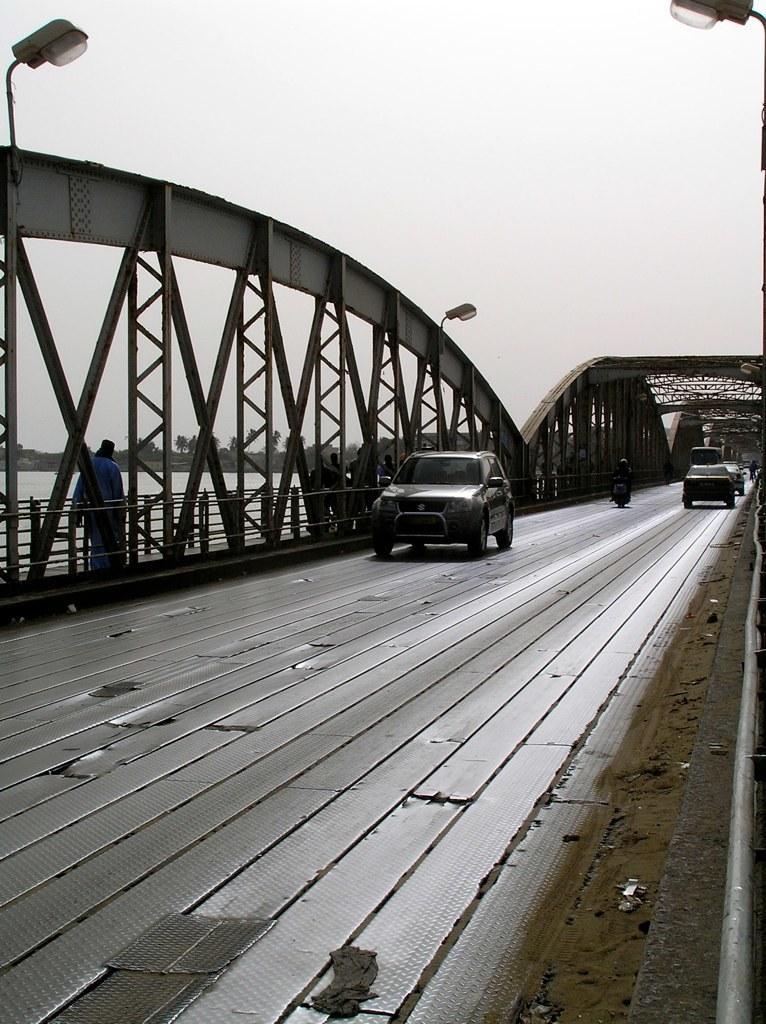Can you describe this image briefly? In this image, we can see bridge and in the center of the image, there are vehicles on the road and at the top, there are lights. 